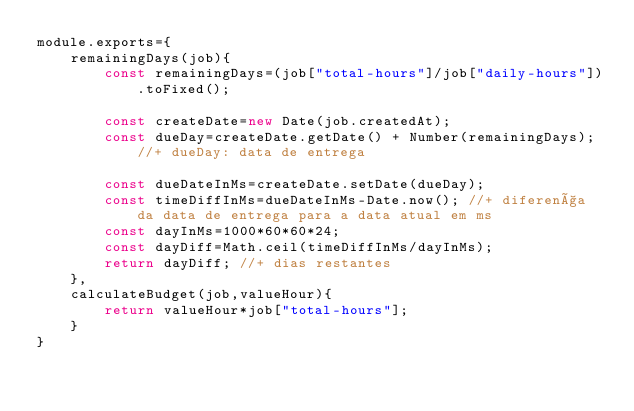<code> <loc_0><loc_0><loc_500><loc_500><_JavaScript_>module.exports={
    remainingDays(job){
        const remainingDays=(job["total-hours"]/job["daily-hours"]).toFixed();
    
        const createDate=new Date(job.createdAt);
        const dueDay=createDate.getDate() + Number(remainingDays); //+ dueDay: data de entrega
    
        const dueDateInMs=createDate.setDate(dueDay);
        const timeDiffInMs=dueDateInMs-Date.now(); //+ diferença da data de entrega para a data atual em ms
        const dayInMs=1000*60*60*24;
        const dayDiff=Math.ceil(timeDiffInMs/dayInMs);
        return dayDiff; //+ dias restantes
    },
    calculateBudget(job,valueHour){
        return valueHour*job["total-hours"];
    }
}</code> 